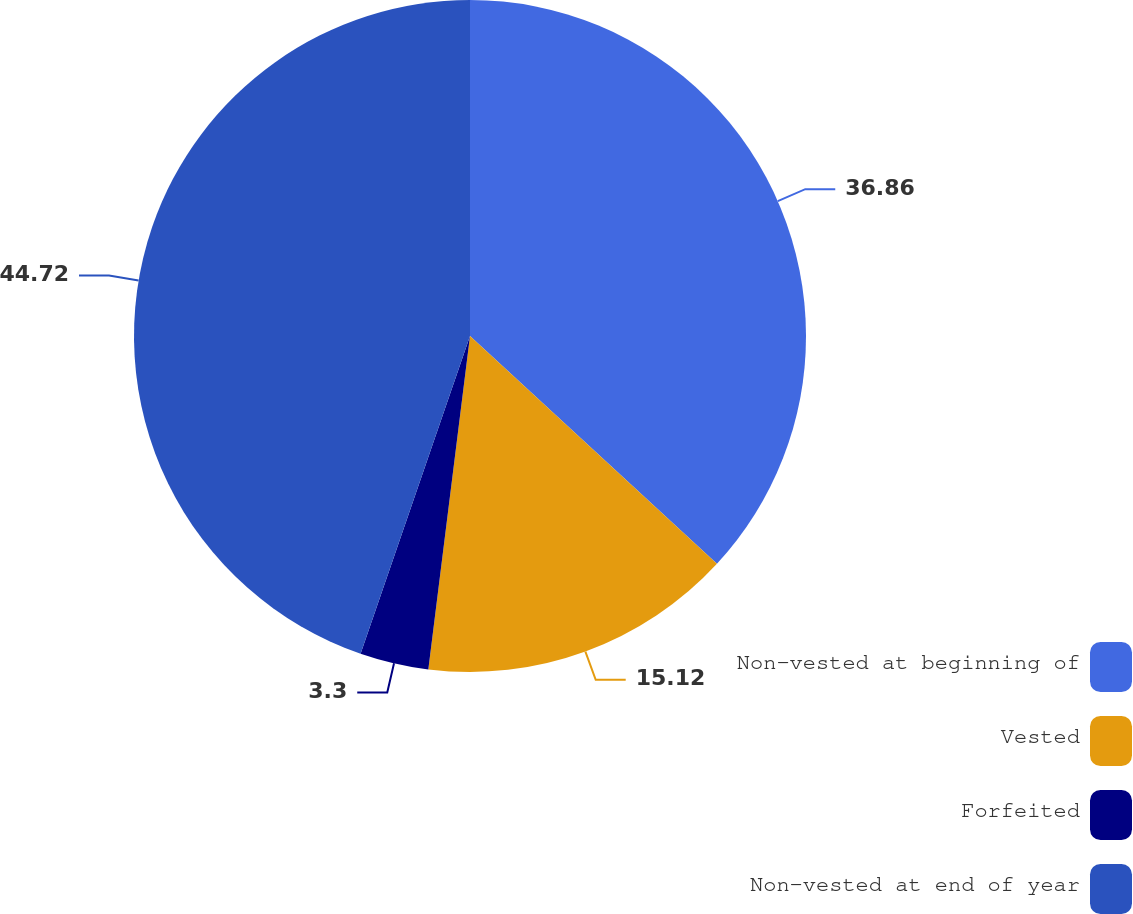Convert chart to OTSL. <chart><loc_0><loc_0><loc_500><loc_500><pie_chart><fcel>Non-vested at beginning of<fcel>Vested<fcel>Forfeited<fcel>Non-vested at end of year<nl><fcel>36.86%<fcel>15.12%<fcel>3.3%<fcel>44.72%<nl></chart> 